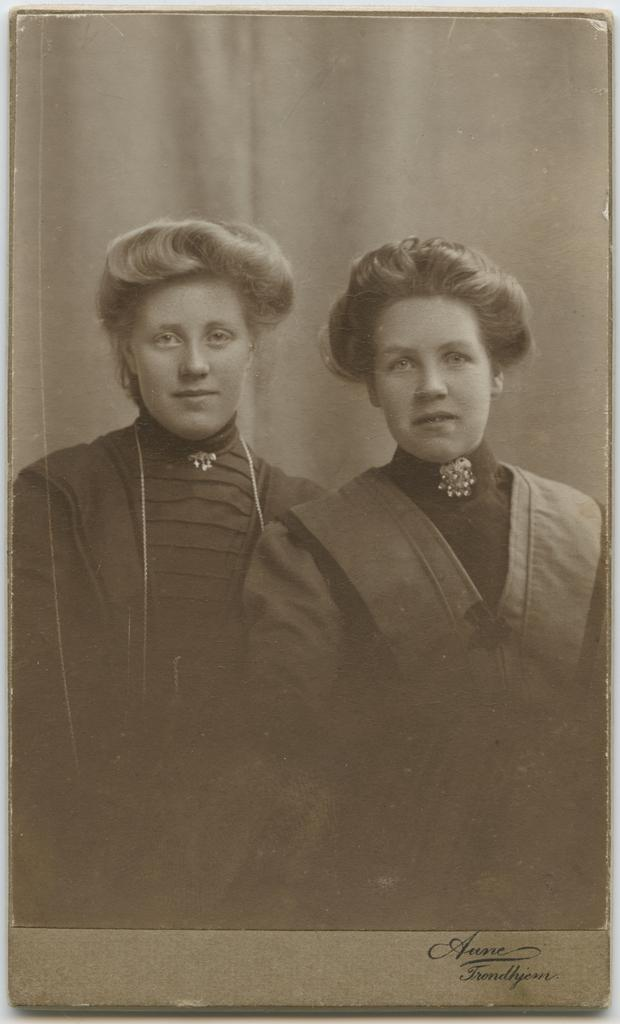How many people are present in the image? There are two people in the image. What are the people wearing? The people are wearing dresses. What is the color scheme of the image? The image is in black and white. What type of underwear can be seen in the image? There is no underwear visible in the image. What is the people drinking in the image? There is no drink, such as eggnog, present in the image. 